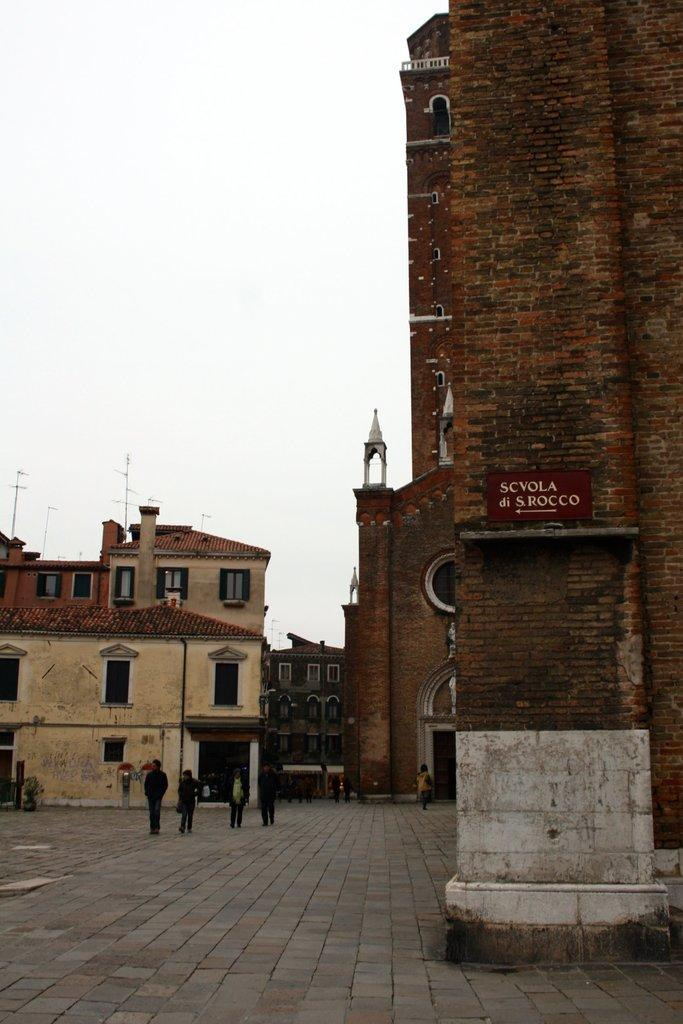What type of structures can be seen in the image? There are buildings in the image. What is the surface in front of the buildings? There is a pavement in front of the buildings. What are the people on the pavement doing? There are people walking on the pavement. Can you tell me how many times the buildings smash into each other in the image? There is no indication in the image that the buildings smash into each other; they are standing upright and separate from one another. 